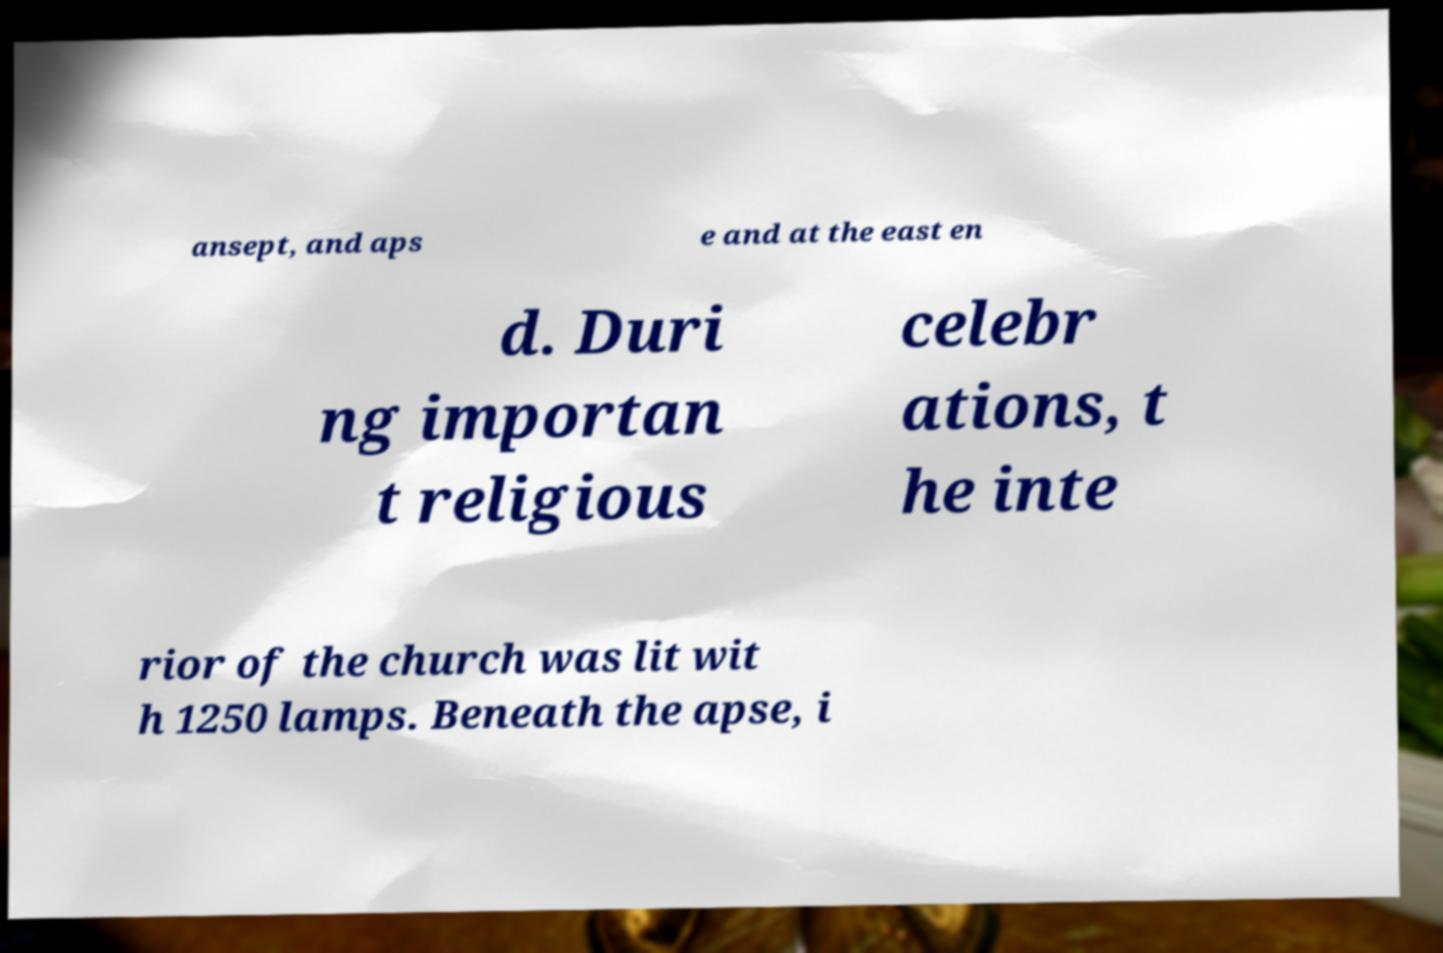Can you accurately transcribe the text from the provided image for me? ansept, and aps e and at the east en d. Duri ng importan t religious celebr ations, t he inte rior of the church was lit wit h 1250 lamps. Beneath the apse, i 